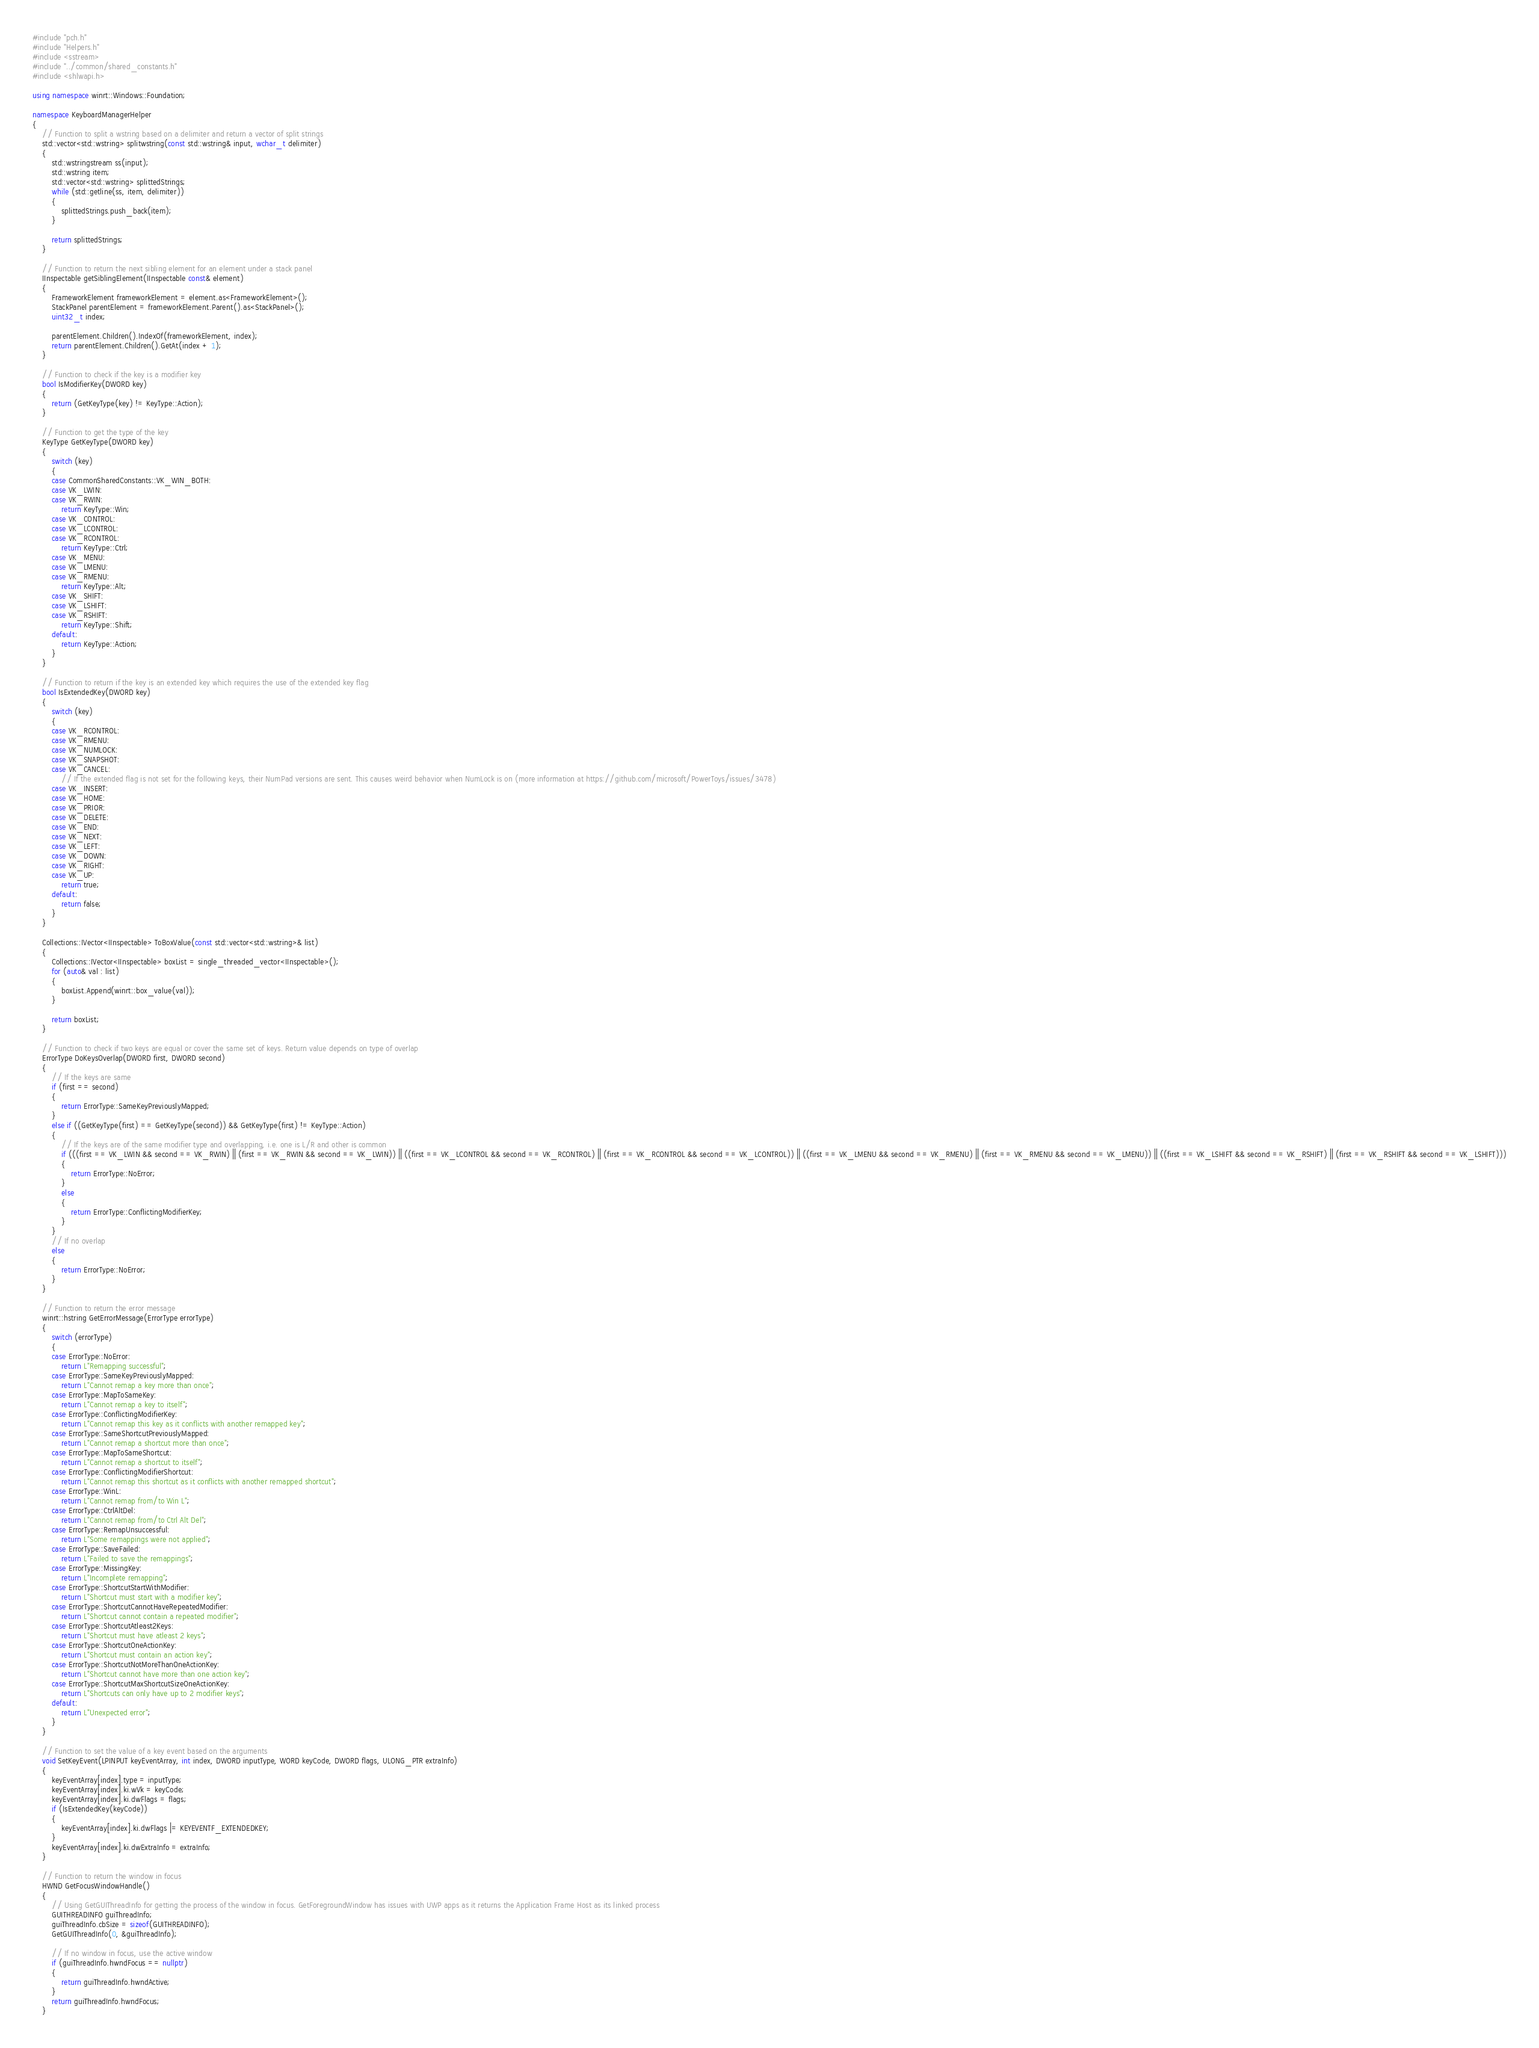Convert code to text. <code><loc_0><loc_0><loc_500><loc_500><_C++_>#include "pch.h"
#include "Helpers.h"
#include <sstream>
#include "../common/shared_constants.h"
#include <shlwapi.h>

using namespace winrt::Windows::Foundation;

namespace KeyboardManagerHelper
{
    // Function to split a wstring based on a delimiter and return a vector of split strings
    std::vector<std::wstring> splitwstring(const std::wstring& input, wchar_t delimiter)
    {
        std::wstringstream ss(input);
        std::wstring item;
        std::vector<std::wstring> splittedStrings;
        while (std::getline(ss, item, delimiter))
        {
            splittedStrings.push_back(item);
        }

        return splittedStrings;
    }

    // Function to return the next sibling element for an element under a stack panel
    IInspectable getSiblingElement(IInspectable const& element)
    {
        FrameworkElement frameworkElement = element.as<FrameworkElement>();
        StackPanel parentElement = frameworkElement.Parent().as<StackPanel>();
        uint32_t index;

        parentElement.Children().IndexOf(frameworkElement, index);
        return parentElement.Children().GetAt(index + 1);
    }

    // Function to check if the key is a modifier key
    bool IsModifierKey(DWORD key)
    {
        return (GetKeyType(key) != KeyType::Action);
    }

    // Function to get the type of the key
    KeyType GetKeyType(DWORD key)
    {
        switch (key)
        {
        case CommonSharedConstants::VK_WIN_BOTH:
        case VK_LWIN:
        case VK_RWIN:
            return KeyType::Win;
        case VK_CONTROL:
        case VK_LCONTROL:
        case VK_RCONTROL:
            return KeyType::Ctrl;
        case VK_MENU:
        case VK_LMENU:
        case VK_RMENU:
            return KeyType::Alt;
        case VK_SHIFT:
        case VK_LSHIFT:
        case VK_RSHIFT:
            return KeyType::Shift;
        default:
            return KeyType::Action;
        }
    }

    // Function to return if the key is an extended key which requires the use of the extended key flag
    bool IsExtendedKey(DWORD key)
    {
        switch (key)
        {
        case VK_RCONTROL:
        case VK_RMENU:
        case VK_NUMLOCK:
        case VK_SNAPSHOT:
        case VK_CANCEL:
            // If the extended flag is not set for the following keys, their NumPad versions are sent. This causes weird behavior when NumLock is on (more information at https://github.com/microsoft/PowerToys/issues/3478)
        case VK_INSERT:
        case VK_HOME:
        case VK_PRIOR:
        case VK_DELETE:
        case VK_END:
        case VK_NEXT:
        case VK_LEFT:
        case VK_DOWN:
        case VK_RIGHT:
        case VK_UP:
            return true;
        default:
            return false;
        }
    }

    Collections::IVector<IInspectable> ToBoxValue(const std::vector<std::wstring>& list)
    {
        Collections::IVector<IInspectable> boxList = single_threaded_vector<IInspectable>();
        for (auto& val : list)
        {
            boxList.Append(winrt::box_value(val));
        }

        return boxList;
    }

    // Function to check if two keys are equal or cover the same set of keys. Return value depends on type of overlap
    ErrorType DoKeysOverlap(DWORD first, DWORD second)
    {
        // If the keys are same
        if (first == second)
        {
            return ErrorType::SameKeyPreviouslyMapped;
        }
        else if ((GetKeyType(first) == GetKeyType(second)) && GetKeyType(first) != KeyType::Action)
        {
            // If the keys are of the same modifier type and overlapping, i.e. one is L/R and other is common
            if (((first == VK_LWIN && second == VK_RWIN) || (first == VK_RWIN && second == VK_LWIN)) || ((first == VK_LCONTROL && second == VK_RCONTROL) || (first == VK_RCONTROL && second == VK_LCONTROL)) || ((first == VK_LMENU && second == VK_RMENU) || (first == VK_RMENU && second == VK_LMENU)) || ((first == VK_LSHIFT && second == VK_RSHIFT) || (first == VK_RSHIFT && second == VK_LSHIFT)))
            {
                return ErrorType::NoError;
            }
            else
            {
                return ErrorType::ConflictingModifierKey;
            }
        }
        // If no overlap
        else
        {
            return ErrorType::NoError;
        }
    }

    // Function to return the error message
    winrt::hstring GetErrorMessage(ErrorType errorType)
    {
        switch (errorType)
        {
        case ErrorType::NoError:
            return L"Remapping successful";
        case ErrorType::SameKeyPreviouslyMapped:
            return L"Cannot remap a key more than once";
        case ErrorType::MapToSameKey:
            return L"Cannot remap a key to itself";
        case ErrorType::ConflictingModifierKey:
            return L"Cannot remap this key as it conflicts with another remapped key";
        case ErrorType::SameShortcutPreviouslyMapped:
            return L"Cannot remap a shortcut more than once";
        case ErrorType::MapToSameShortcut:
            return L"Cannot remap a shortcut to itself";
        case ErrorType::ConflictingModifierShortcut:
            return L"Cannot remap this shortcut as it conflicts with another remapped shortcut";
        case ErrorType::WinL:
            return L"Cannot remap from/to Win L";
        case ErrorType::CtrlAltDel:
            return L"Cannot remap from/to Ctrl Alt Del";
        case ErrorType::RemapUnsuccessful:
            return L"Some remappings were not applied";
        case ErrorType::SaveFailed:
            return L"Failed to save the remappings";
        case ErrorType::MissingKey:
            return L"Incomplete remapping";
        case ErrorType::ShortcutStartWithModifier:
            return L"Shortcut must start with a modifier key";
        case ErrorType::ShortcutCannotHaveRepeatedModifier:
            return L"Shortcut cannot contain a repeated modifier";
        case ErrorType::ShortcutAtleast2Keys:
            return L"Shortcut must have atleast 2 keys";
        case ErrorType::ShortcutOneActionKey:
            return L"Shortcut must contain an action key";
        case ErrorType::ShortcutNotMoreThanOneActionKey:
            return L"Shortcut cannot have more than one action key";
        case ErrorType::ShortcutMaxShortcutSizeOneActionKey:
            return L"Shortcuts can only have up to 2 modifier keys";
        default:
            return L"Unexpected error";
        }
    }

    // Function to set the value of a key event based on the arguments
    void SetKeyEvent(LPINPUT keyEventArray, int index, DWORD inputType, WORD keyCode, DWORD flags, ULONG_PTR extraInfo)
    {
        keyEventArray[index].type = inputType;
        keyEventArray[index].ki.wVk = keyCode;
        keyEventArray[index].ki.dwFlags = flags;
        if (IsExtendedKey(keyCode))
        {
            keyEventArray[index].ki.dwFlags |= KEYEVENTF_EXTENDEDKEY;
        }
        keyEventArray[index].ki.dwExtraInfo = extraInfo;
    }

    // Function to return the window in focus
    HWND GetFocusWindowHandle()
    {
        // Using GetGUIThreadInfo for getting the process of the window in focus. GetForegroundWindow has issues with UWP apps as it returns the Application Frame Host as its linked process
        GUITHREADINFO guiThreadInfo;
        guiThreadInfo.cbSize = sizeof(GUITHREADINFO);
        GetGUIThreadInfo(0, &guiThreadInfo);

        // If no window in focus, use the active window
        if (guiThreadInfo.hwndFocus == nullptr)
        {
            return guiThreadInfo.hwndActive;
        }
        return guiThreadInfo.hwndFocus;
    }
</code> 